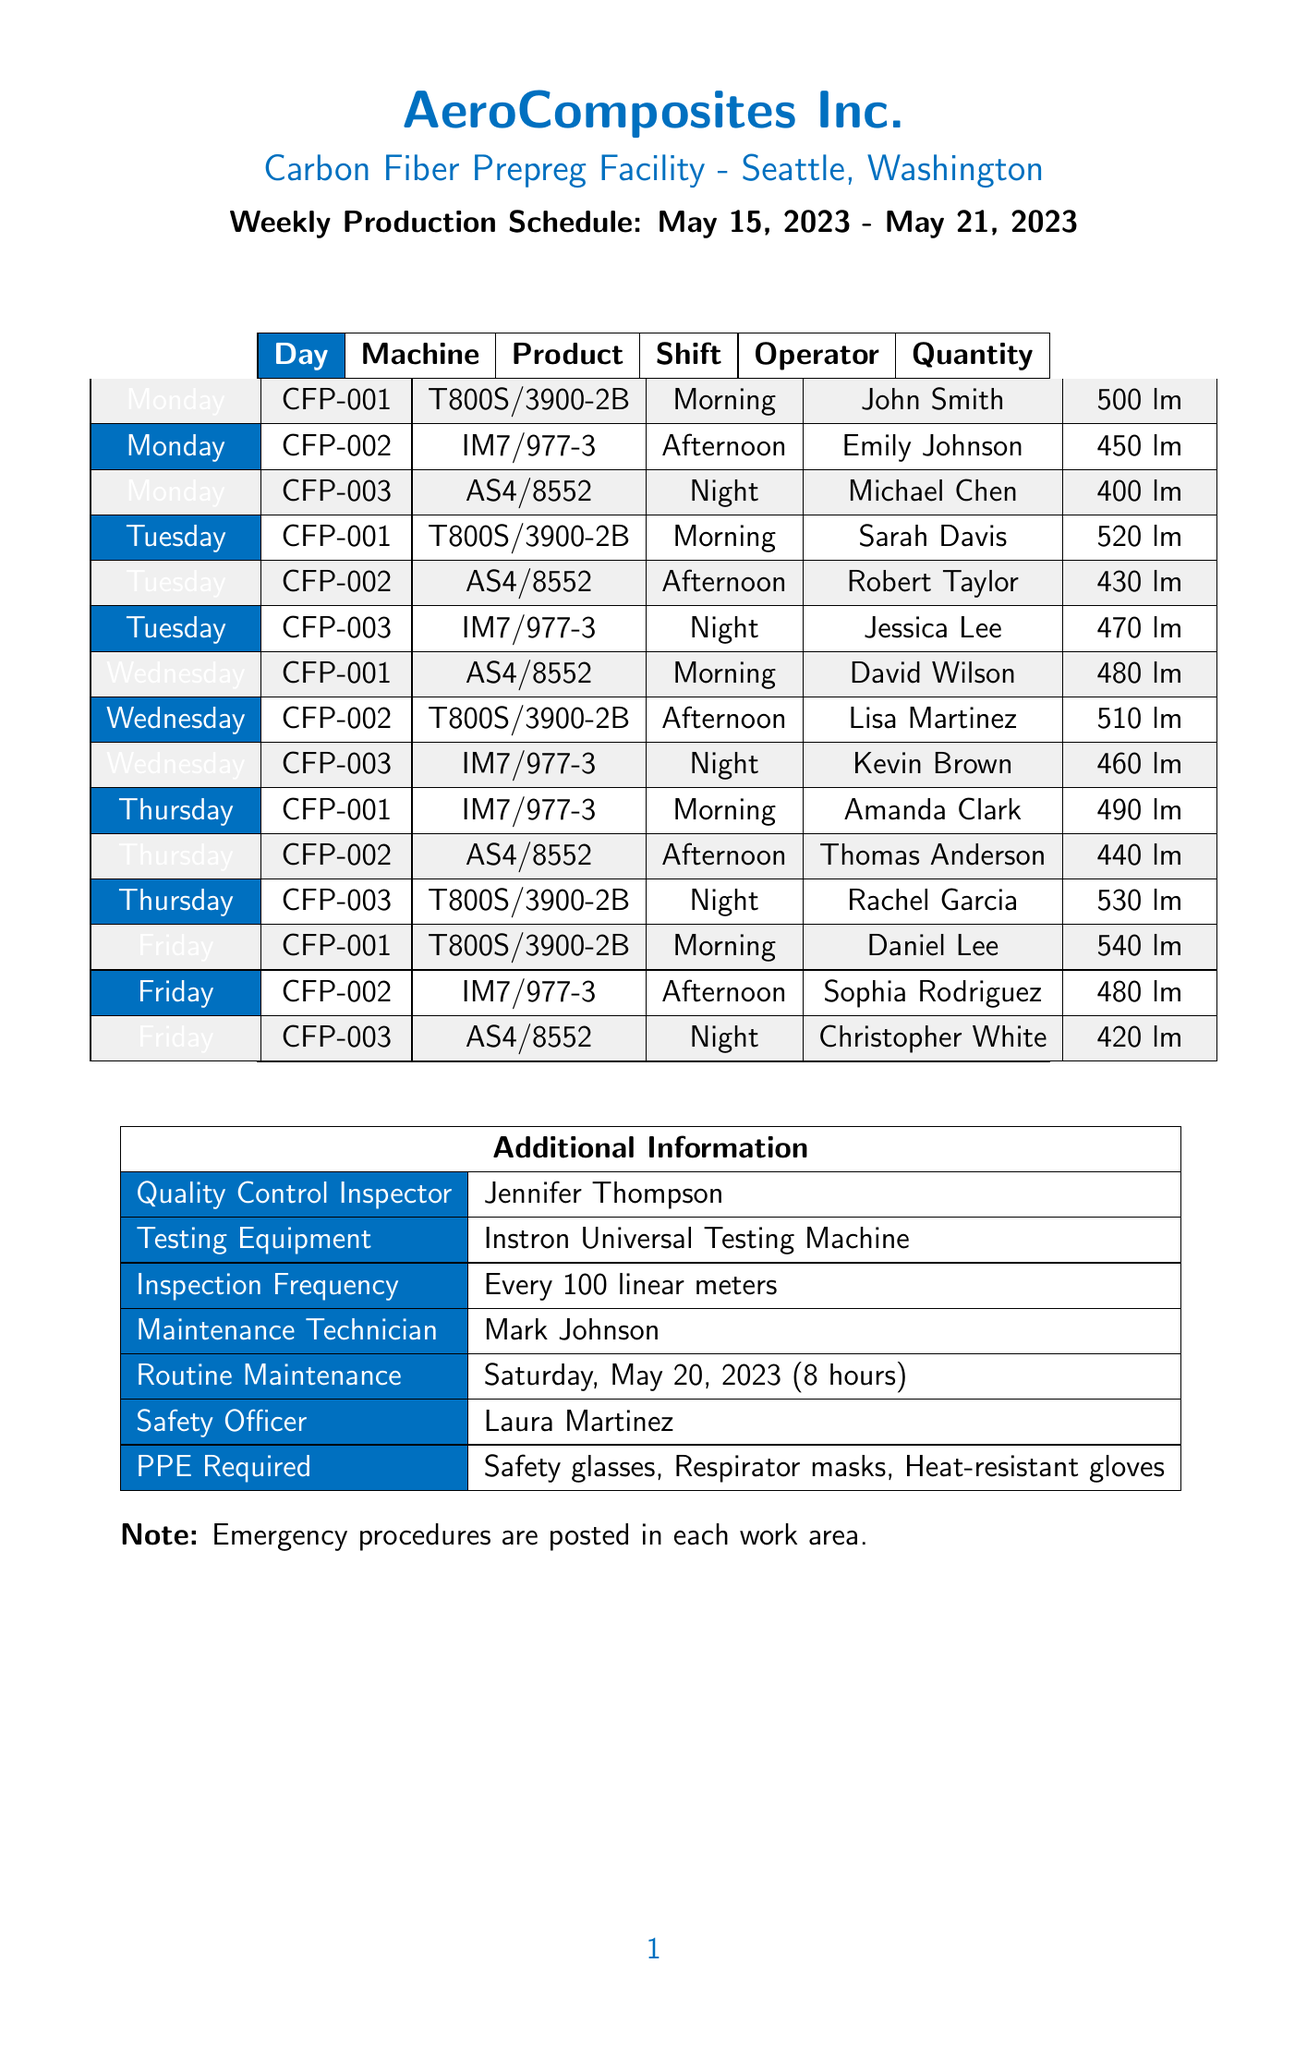what is the name of the company? The name of the company is stated at the top of the document as AeroComposites Inc.
Answer: AeroComposites Inc what is the location of the production facility? The location is specified as Seattle, Washington in the document.
Answer: Seattle, Washington who is the quality control inspector? The document lists Jennifer Thompson as the quality control inspector.
Answer: Jennifer Thompson how many linear meters of T800S/3900-2B Carbon Fiber Prepreg are produced on Friday? The schedule indicates that 540 linear meters of T800S/3900-2B Carbon Fiber Prepreg are produced on Friday.
Answer: 540 linear meters which machine is assigned to produce IM7/977-3 Carbon Fiber Prepreg on Tuesday? The document shows that machine CFP-003 is assigned to produce IM7/977-3 Carbon Fiber Prepreg on Tuesday during Night Shift.
Answer: CFP-003 what is the maintenance duration scheduled for Saturday? The maintenance duration is explicitly stated as 8 hours in the document.
Answer: 8 hours who operates the Hexcel Prepreg Production System on Monday? The document states that Emily Johnson operates the Hexcel Prepreg Production System during the Afternoon Shift.
Answer: Emily Johnson how many shifts are there in the production schedule? The document lists three shifts: Morning, Afternoon, and Night, making a total of 3 shifts.
Answer: 3 shifts what is the inspection frequency for quality control? The document specifies that the inspection frequency is every 100 linear meters.
Answer: Every 100 linear meters 